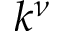<formula> <loc_0><loc_0><loc_500><loc_500>k ^ { \nu }</formula> 